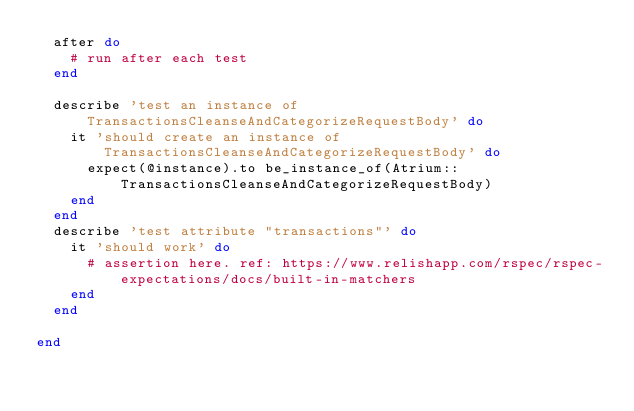Convert code to text. <code><loc_0><loc_0><loc_500><loc_500><_Ruby_>  after do
    # run after each test
  end

  describe 'test an instance of TransactionsCleanseAndCategorizeRequestBody' do
    it 'should create an instance of TransactionsCleanseAndCategorizeRequestBody' do
      expect(@instance).to be_instance_of(Atrium::TransactionsCleanseAndCategorizeRequestBody)
    end
  end
  describe 'test attribute "transactions"' do
    it 'should work' do
      # assertion here. ref: https://www.relishapp.com/rspec/rspec-expectations/docs/built-in-matchers
    end
  end

end
</code> 